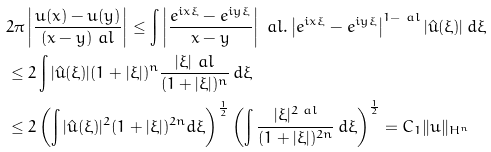Convert formula to latex. <formula><loc_0><loc_0><loc_500><loc_500>& 2 \pi \left | \frac { u ( x ) - u ( y ) } { ( x - y ) ^ { \ } a l } \right | \leq \int \left | \frac { e ^ { i x \xi } - e ^ { i y \xi } } { x - y } \right | ^ { \ } a l . \left | e ^ { i x \xi } - e ^ { i y \xi } \right | ^ { 1 - \ a l } | \hat { u } ( \xi ) | \, d \xi \\ & \leq 2 \int | \hat { u } ( \xi ) | ( 1 + | \xi | ) ^ { n } \frac { | \xi | ^ { \ } a l } { ( 1 + | \xi | ) ^ { n } } \, d \xi \\ & \leq 2 \left ( \int | \hat { u } ( \xi ) | ^ { 2 } ( 1 + | \xi | ) ^ { 2 n } d \xi \right ) ^ { \frac { 1 } { 2 } } \left ( \int \frac { | \xi | ^ { 2 \ a l } } { ( 1 + | \xi | ) ^ { 2 n } } \, d \xi \right ) ^ { \frac { 1 } { 2 } } = C _ { 1 } \| u \| _ { H ^ { n } }</formula> 